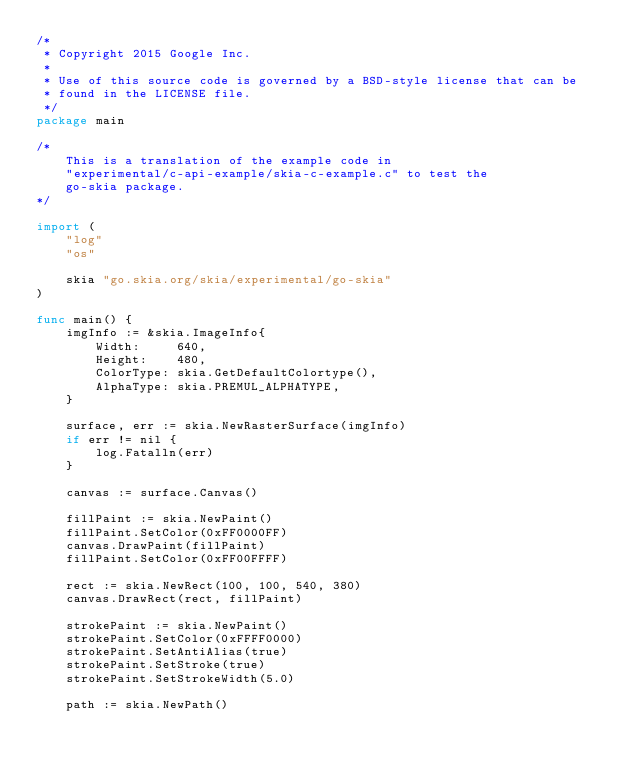Convert code to text. <code><loc_0><loc_0><loc_500><loc_500><_Go_>/*
 * Copyright 2015 Google Inc.
 *
 * Use of this source code is governed by a BSD-style license that can be
 * found in the LICENSE file.
 */
package main

/*
	This is a translation of the example code in
	"experimental/c-api-example/skia-c-example.c" to test the
	go-skia package.
*/

import (
	"log"
	"os"

	skia "go.skia.org/skia/experimental/go-skia"
)

func main() {
	imgInfo := &skia.ImageInfo{
		Width:     640,
		Height:    480,
		ColorType: skia.GetDefaultColortype(),
		AlphaType: skia.PREMUL_ALPHATYPE,
	}

	surface, err := skia.NewRasterSurface(imgInfo)
	if err != nil {
		log.Fatalln(err)
	}

	canvas := surface.Canvas()

	fillPaint := skia.NewPaint()
	fillPaint.SetColor(0xFF0000FF)
	canvas.DrawPaint(fillPaint)
	fillPaint.SetColor(0xFF00FFFF)

	rect := skia.NewRect(100, 100, 540, 380)
	canvas.DrawRect(rect, fillPaint)

	strokePaint := skia.NewPaint()
	strokePaint.SetColor(0xFFFF0000)
	strokePaint.SetAntiAlias(true)
	strokePaint.SetStroke(true)
	strokePaint.SetStrokeWidth(5.0)

	path := skia.NewPath()</code> 